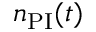<formula> <loc_0><loc_0><loc_500><loc_500>n _ { P I } ( t )</formula> 